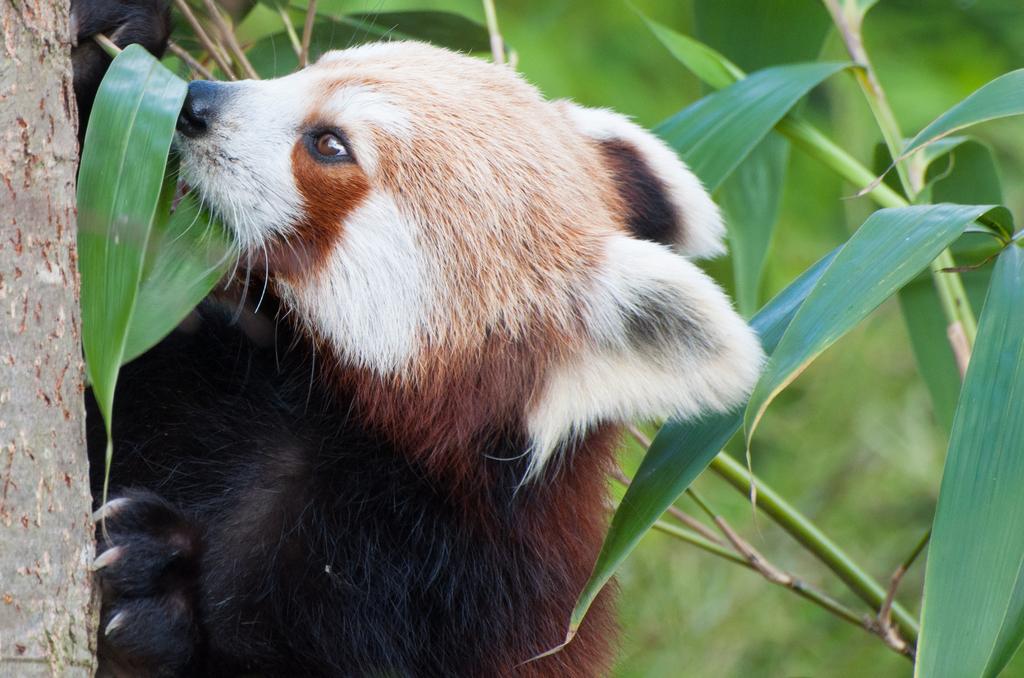In one or two sentences, can you explain what this image depicts? In the center of the image an animal is present. On the right side of the image leaves are present. On the left side of the image tree is there. 